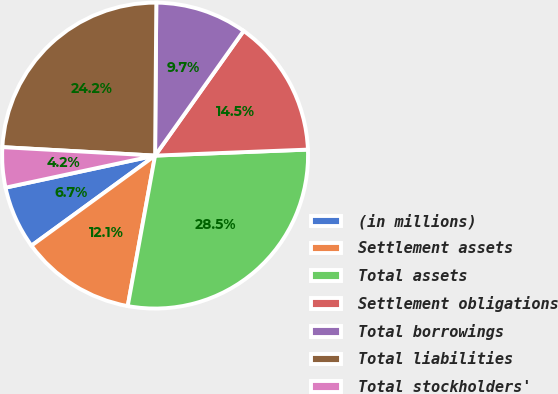Convert chart to OTSL. <chart><loc_0><loc_0><loc_500><loc_500><pie_chart><fcel>(in millions)<fcel>Settlement assets<fcel>Total assets<fcel>Settlement obligations<fcel>Total borrowings<fcel>Total liabilities<fcel>Total stockholders'<nl><fcel>6.66%<fcel>12.12%<fcel>28.49%<fcel>14.55%<fcel>9.7%<fcel>24.25%<fcel>4.24%<nl></chart> 